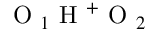<formula> <loc_0><loc_0><loc_500><loc_500>O _ { 1 } H ^ { + } O _ { 2 }</formula> 